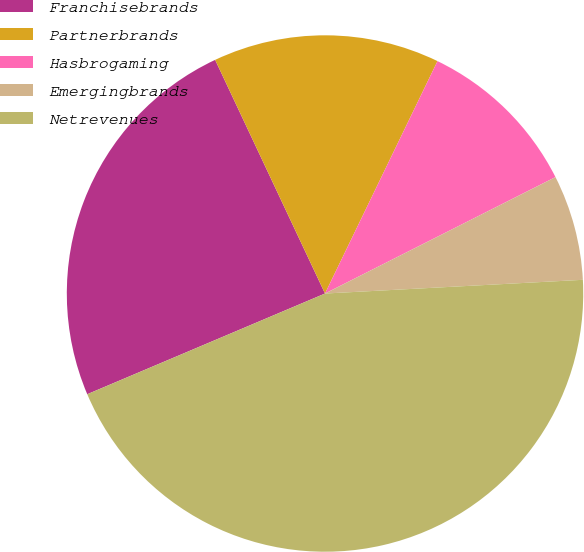Convert chart to OTSL. <chart><loc_0><loc_0><loc_500><loc_500><pie_chart><fcel>Franchisebrands<fcel>Partnerbrands<fcel>Hasbrogaming<fcel>Emergingbrands<fcel>Netrevenues<nl><fcel>24.38%<fcel>14.17%<fcel>10.38%<fcel>6.6%<fcel>44.47%<nl></chart> 